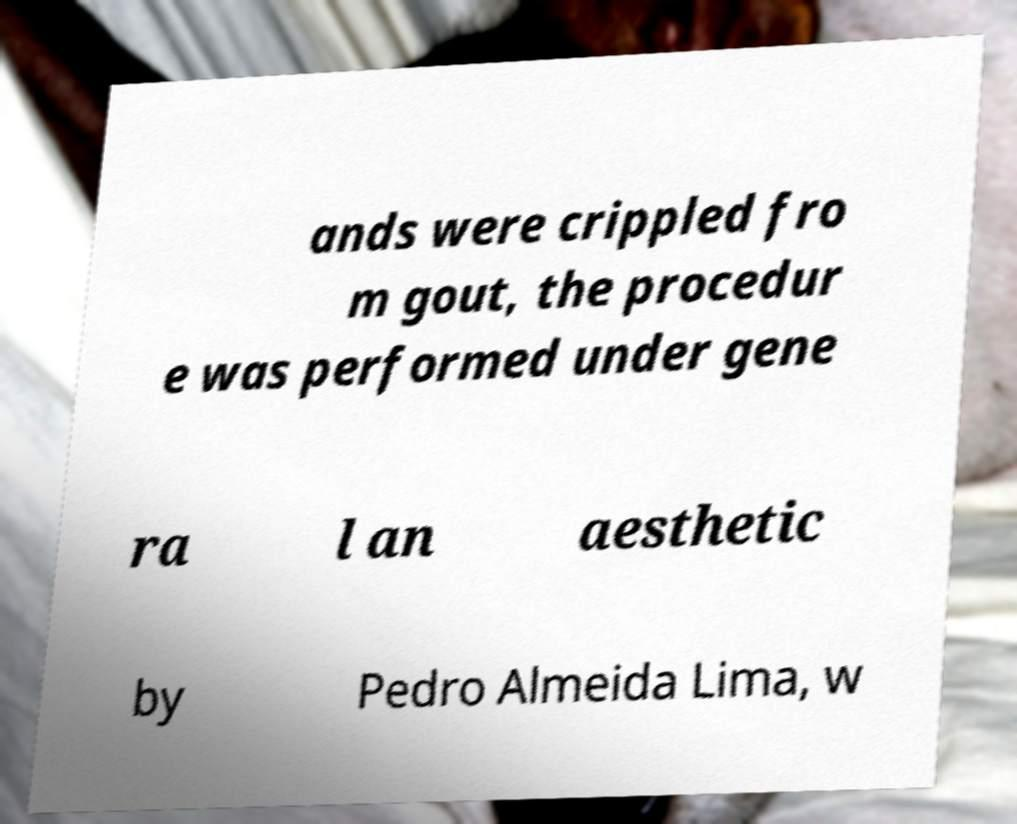Can you read and provide the text displayed in the image?This photo seems to have some interesting text. Can you extract and type it out for me? ands were crippled fro m gout, the procedur e was performed under gene ra l an aesthetic by Pedro Almeida Lima, w 